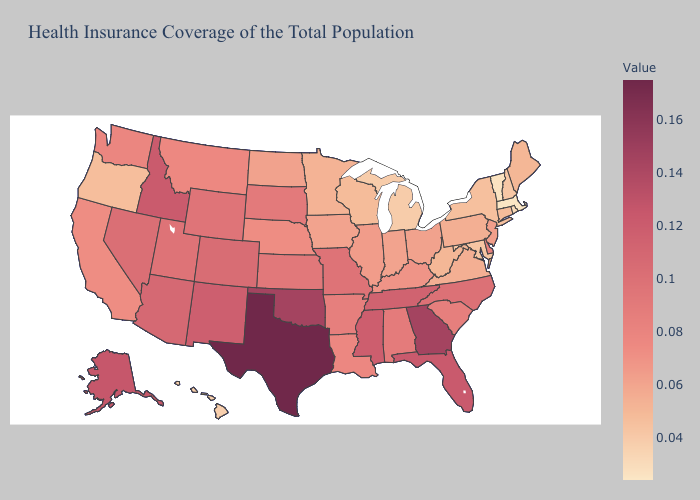Does Oklahoma have the highest value in the South?
Concise answer only. No. Does New Jersey have a higher value than New Hampshire?
Short answer required. Yes. Does Hawaii have the lowest value in the West?
Give a very brief answer. Yes. Does Texas have the highest value in the USA?
Short answer required. Yes. Does Massachusetts have the highest value in the Northeast?
Write a very short answer. No. Which states have the lowest value in the USA?
Short answer required. Massachusetts. Which states have the lowest value in the West?
Short answer required. Hawaii. 